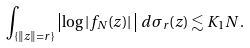Convert formula to latex. <formula><loc_0><loc_0><loc_500><loc_500>\int _ { \{ \| z \| = r \} } \left | \log | f _ { N } ( z ) | \, \right | \, d \sigma _ { r } ( z ) \lesssim K _ { 1 } N \, .</formula> 